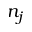Convert formula to latex. <formula><loc_0><loc_0><loc_500><loc_500>n _ { j }</formula> 